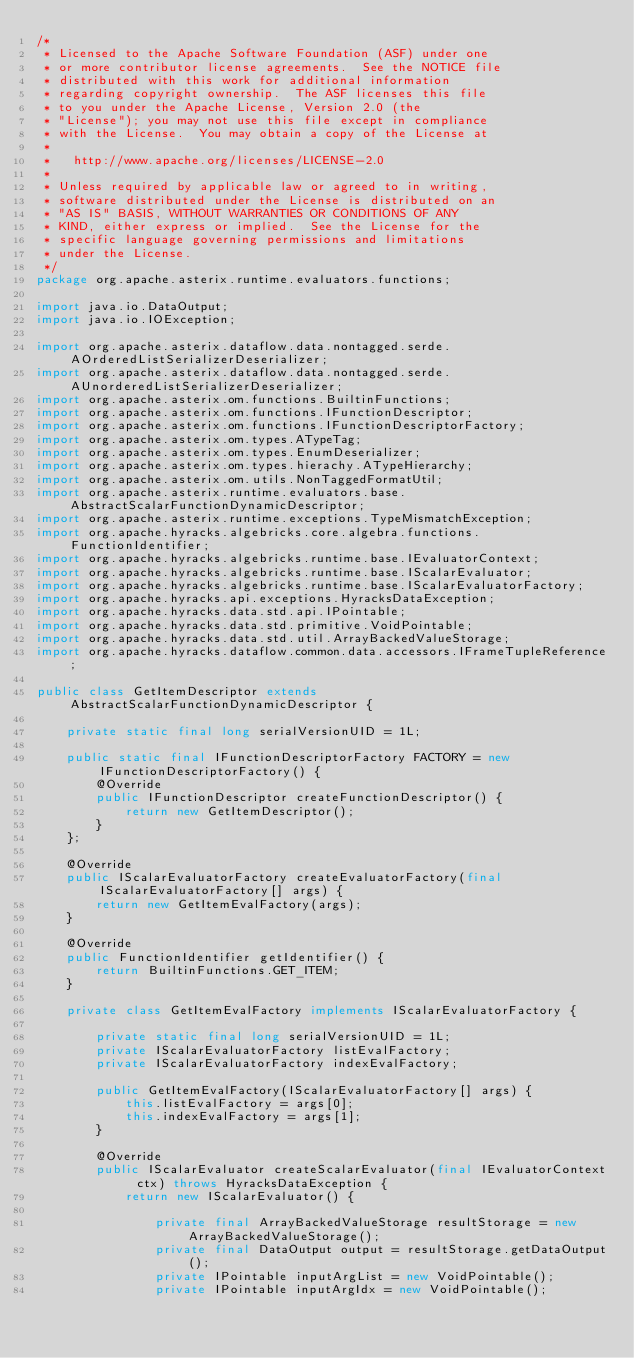<code> <loc_0><loc_0><loc_500><loc_500><_Java_>/*
 * Licensed to the Apache Software Foundation (ASF) under one
 * or more contributor license agreements.  See the NOTICE file
 * distributed with this work for additional information
 * regarding copyright ownership.  The ASF licenses this file
 * to you under the Apache License, Version 2.0 (the
 * "License"); you may not use this file except in compliance
 * with the License.  You may obtain a copy of the License at
 *
 *   http://www.apache.org/licenses/LICENSE-2.0
 *
 * Unless required by applicable law or agreed to in writing,
 * software distributed under the License is distributed on an
 * "AS IS" BASIS, WITHOUT WARRANTIES OR CONDITIONS OF ANY
 * KIND, either express or implied.  See the License for the
 * specific language governing permissions and limitations
 * under the License.
 */
package org.apache.asterix.runtime.evaluators.functions;

import java.io.DataOutput;
import java.io.IOException;

import org.apache.asterix.dataflow.data.nontagged.serde.AOrderedListSerializerDeserializer;
import org.apache.asterix.dataflow.data.nontagged.serde.AUnorderedListSerializerDeserializer;
import org.apache.asterix.om.functions.BuiltinFunctions;
import org.apache.asterix.om.functions.IFunctionDescriptor;
import org.apache.asterix.om.functions.IFunctionDescriptorFactory;
import org.apache.asterix.om.types.ATypeTag;
import org.apache.asterix.om.types.EnumDeserializer;
import org.apache.asterix.om.types.hierachy.ATypeHierarchy;
import org.apache.asterix.om.utils.NonTaggedFormatUtil;
import org.apache.asterix.runtime.evaluators.base.AbstractScalarFunctionDynamicDescriptor;
import org.apache.asterix.runtime.exceptions.TypeMismatchException;
import org.apache.hyracks.algebricks.core.algebra.functions.FunctionIdentifier;
import org.apache.hyracks.algebricks.runtime.base.IEvaluatorContext;
import org.apache.hyracks.algebricks.runtime.base.IScalarEvaluator;
import org.apache.hyracks.algebricks.runtime.base.IScalarEvaluatorFactory;
import org.apache.hyracks.api.exceptions.HyracksDataException;
import org.apache.hyracks.data.std.api.IPointable;
import org.apache.hyracks.data.std.primitive.VoidPointable;
import org.apache.hyracks.data.std.util.ArrayBackedValueStorage;
import org.apache.hyracks.dataflow.common.data.accessors.IFrameTupleReference;

public class GetItemDescriptor extends AbstractScalarFunctionDynamicDescriptor {

    private static final long serialVersionUID = 1L;

    public static final IFunctionDescriptorFactory FACTORY = new IFunctionDescriptorFactory() {
        @Override
        public IFunctionDescriptor createFunctionDescriptor() {
            return new GetItemDescriptor();
        }
    };

    @Override
    public IScalarEvaluatorFactory createEvaluatorFactory(final IScalarEvaluatorFactory[] args) {
        return new GetItemEvalFactory(args);
    }

    @Override
    public FunctionIdentifier getIdentifier() {
        return BuiltinFunctions.GET_ITEM;
    }

    private class GetItemEvalFactory implements IScalarEvaluatorFactory {

        private static final long serialVersionUID = 1L;
        private IScalarEvaluatorFactory listEvalFactory;
        private IScalarEvaluatorFactory indexEvalFactory;

        public GetItemEvalFactory(IScalarEvaluatorFactory[] args) {
            this.listEvalFactory = args[0];
            this.indexEvalFactory = args[1];
        }

        @Override
        public IScalarEvaluator createScalarEvaluator(final IEvaluatorContext ctx) throws HyracksDataException {
            return new IScalarEvaluator() {

                private final ArrayBackedValueStorage resultStorage = new ArrayBackedValueStorage();
                private final DataOutput output = resultStorage.getDataOutput();
                private IPointable inputArgList = new VoidPointable();
                private IPointable inputArgIdx = new VoidPointable();</code> 